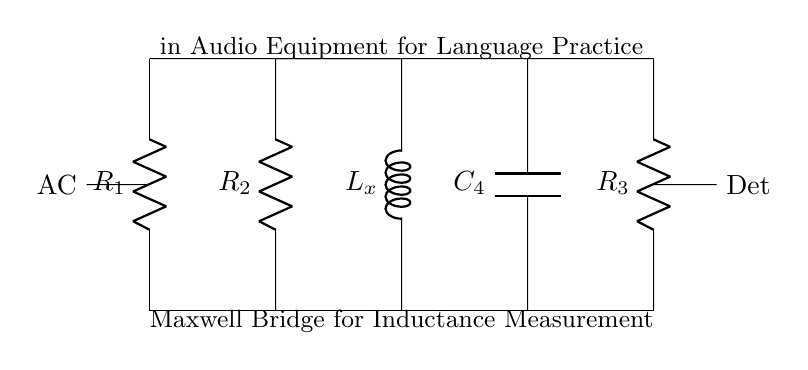What components are present in this circuit? The circuit includes three resistors, one capacitor, and one inductor. These components are labeled as R1, R2, R3, C4, and Lx respectively, and visually represented in the diagram.
Answer: Three resistors, one capacitor, one inductor What is the purpose of the inductor labeled as Lx? The inductor Lx is used for measuring inductance in the Maxwell Bridge setup; it is the unknown inductance that the circuit aims to balance against known components.
Answer: Measuring inductance How many resistors are present in this circuit? There are three resistors indicated by R1, R2, and R3 in the diagram. This is confirmed by counting the labeled resistor components.
Answer: Three What type of circuit is indicated by the connections and components? The circuit is a Maxwell Bridge, which is specifically designed for inductance measurement, as shown by the arrangement of known resistances and the presence of an inductor.
Answer: Maxwell Bridge What does AC represent in the circuit? AC represents the alternating current input to the circuit, which is critical for the operation of the bridge and inductance measurement, shown on the left side of the diagram.
Answer: Alternating current How could the circuit be used in language practice equipment? This circuit could enhance the sound quality in audio equipment for language learning by measuring and compensating for inductive effects, crucial for audio clarity.
Answer: Sound quality enhancement 